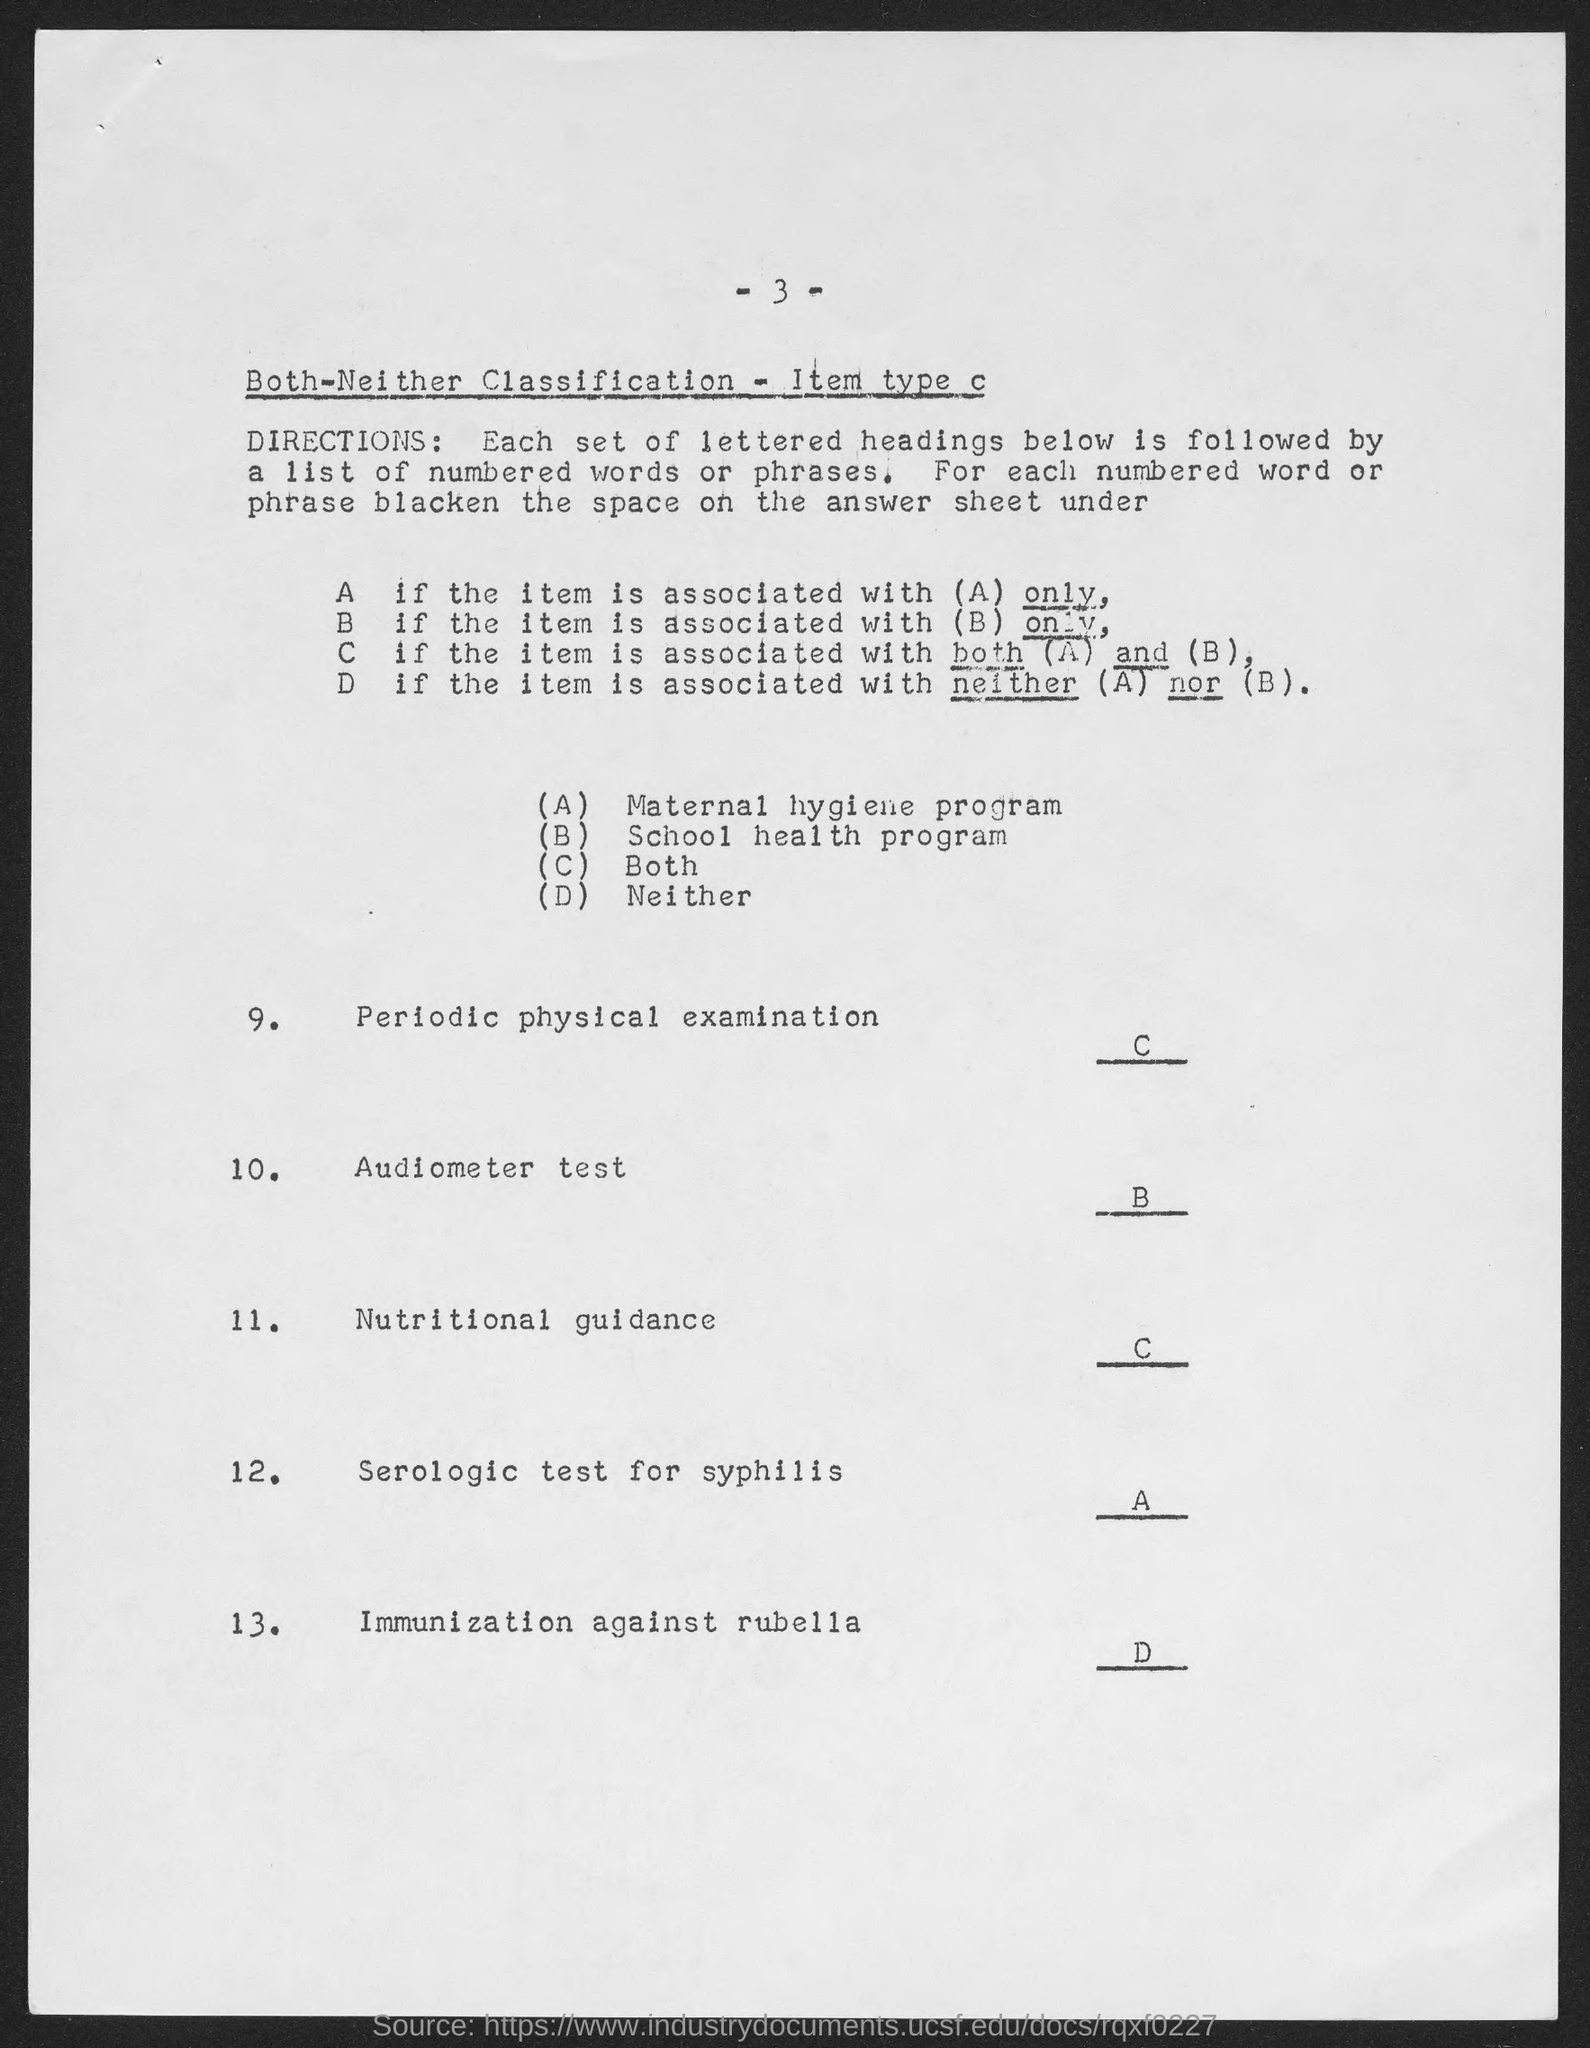What is the option for periodic physical examination?
Provide a short and direct response. C. 